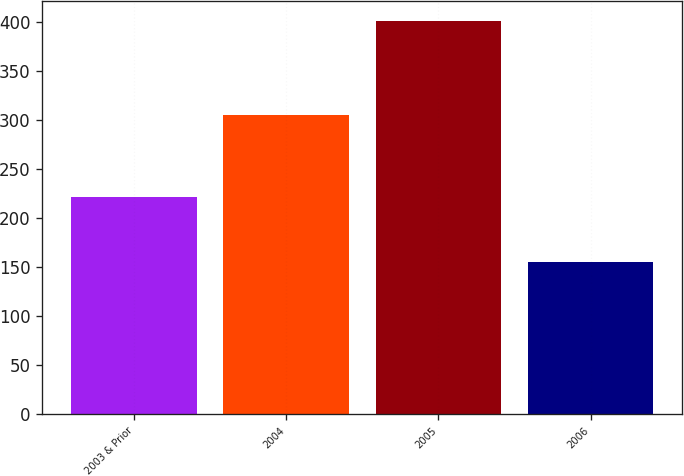<chart> <loc_0><loc_0><loc_500><loc_500><bar_chart><fcel>2003 & Prior<fcel>2004<fcel>2005<fcel>2006<nl><fcel>222<fcel>306<fcel>402<fcel>155<nl></chart> 